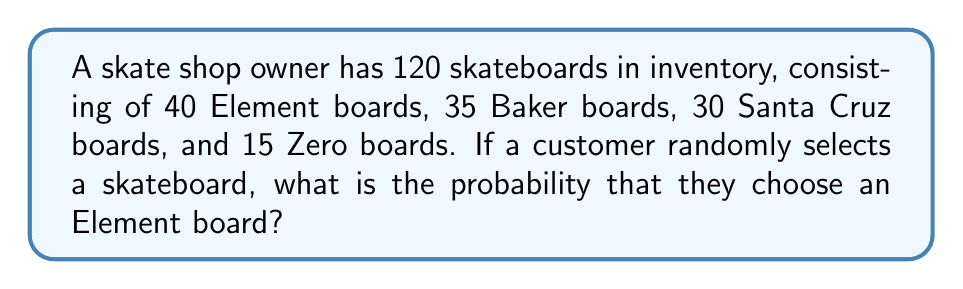Could you help me with this problem? To solve this problem, we need to follow these steps:

1. Identify the total number of skateboards in the inventory:
   Total skateboards = 40 + 35 + 30 + 15 = 120

2. Identify the number of favorable outcomes (Element boards):
   Number of Element boards = 40

3. Calculate the probability using the formula:
   $$P(\text{Element}) = \frac{\text{Number of Element boards}}{\text{Total number of skateboards}}$$

4. Substitute the values:
   $$P(\text{Element}) = \frac{40}{120}$$

5. Simplify the fraction:
   $$P(\text{Element}) = \frac{1}{3}$$

Therefore, the probability of randomly selecting an Element board is $\frac{1}{3}$ or approximately 0.3333 (33.33%).
Answer: $\frac{1}{3}$ 